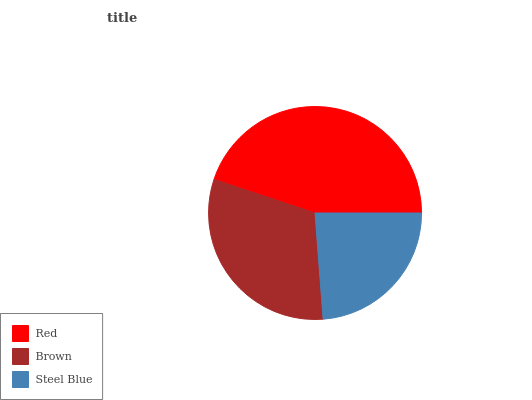Is Steel Blue the minimum?
Answer yes or no. Yes. Is Red the maximum?
Answer yes or no. Yes. Is Brown the minimum?
Answer yes or no. No. Is Brown the maximum?
Answer yes or no. No. Is Red greater than Brown?
Answer yes or no. Yes. Is Brown less than Red?
Answer yes or no. Yes. Is Brown greater than Red?
Answer yes or no. No. Is Red less than Brown?
Answer yes or no. No. Is Brown the high median?
Answer yes or no. Yes. Is Brown the low median?
Answer yes or no. Yes. Is Steel Blue the high median?
Answer yes or no. No. Is Red the low median?
Answer yes or no. No. 